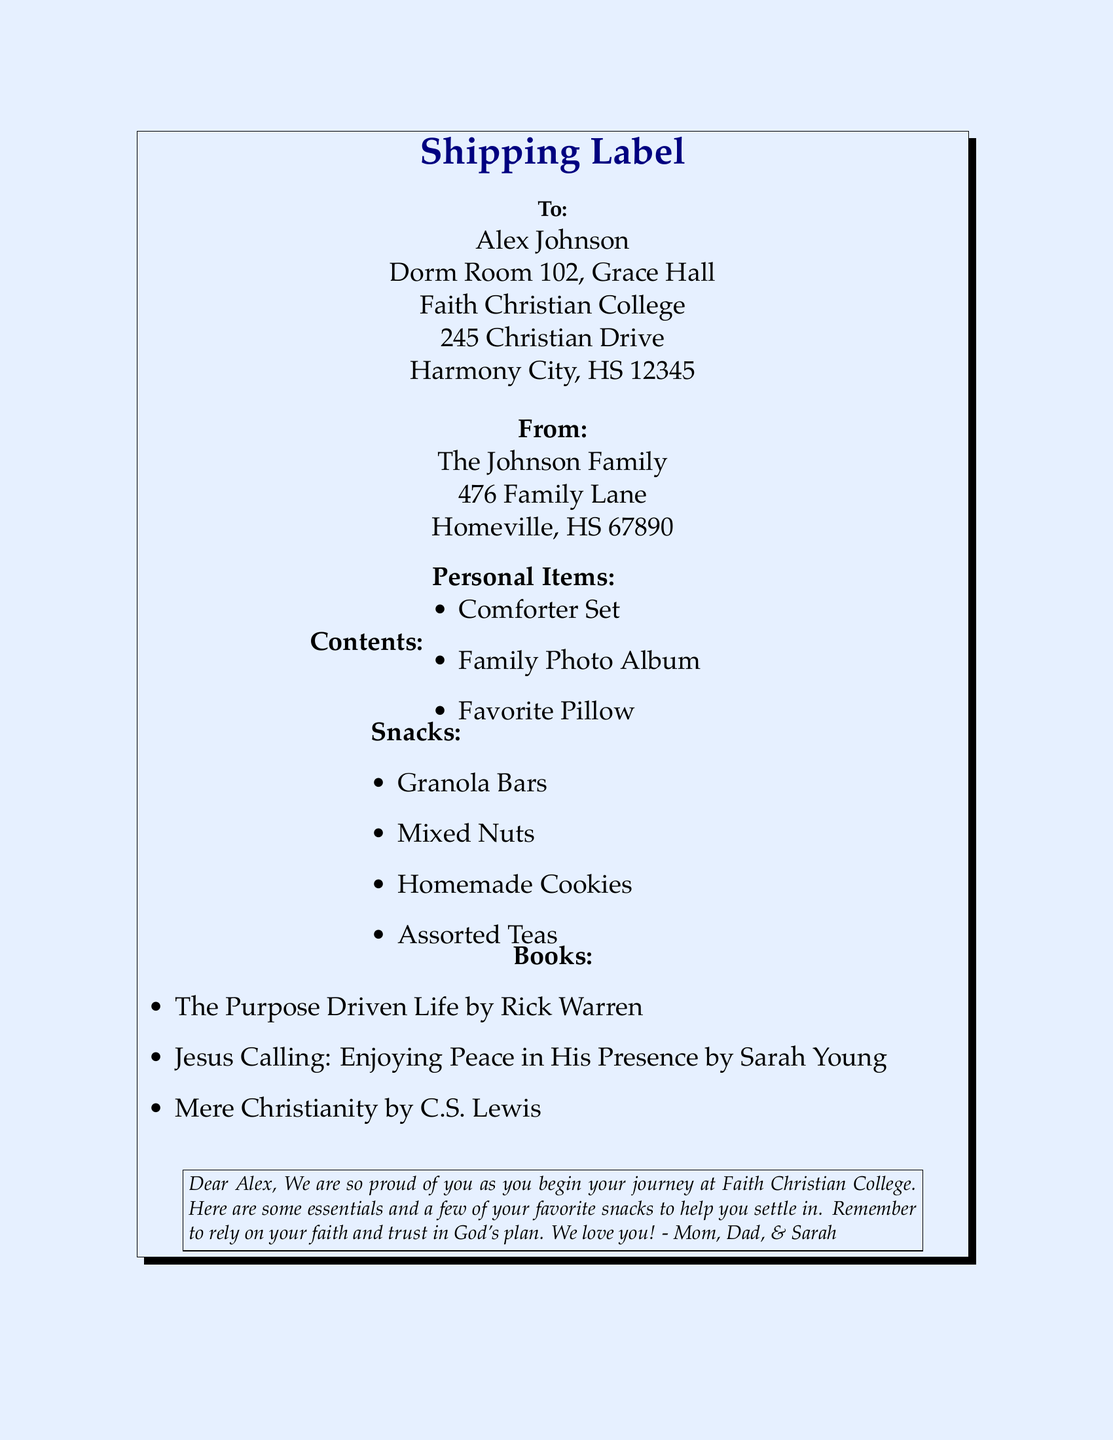What is the recipient's name? The recipient's name is clearly stated at the top of the shipping label.
Answer: Alex Johnson What is the sender's family name? The sender's family name is mentioned under "From", identifying the sender.
Answer: The Johnson Family What is the college's name? The name of the college is indicated near the recipient's address.
Answer: Faith Christian College How many personal items are listed? By counting the personal items in the document, we can determine the quantity.
Answer: Three What type of snacks are included? The list of snacks is provided under the contents section, detailing each item.
Answer: Granola Bars Which book is authored by C.S. Lewis? The book authored by C.S. Lewis is specified in the list of books.
Answer: Mere Christianity What is the message from the family? The family message is enclosed in the box at the bottom of the document.
Answer: Dear Alex, We are so proud of you as you begin your journey at Faith Christian College.. What is the address of the Johnson Family? The complete address of the sender is listed for delivery purposes.
Answer: 476 Family Lane, Homeville, HS 67890 What is the main color of the background? The background color is specified and can be identified visually.
Answer: Light blue 